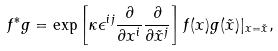<formula> <loc_0><loc_0><loc_500><loc_500>f ^ { * } g = \exp \left [ \kappa \epsilon ^ { i j } \frac { \partial } { \partial x ^ { i } } \frac { \partial } { \partial \tilde { x } ^ { j } } \right ] f ( { x } ) g ( { \tilde { x } } ) | _ { { x } = { \tilde { x } } } ,</formula> 